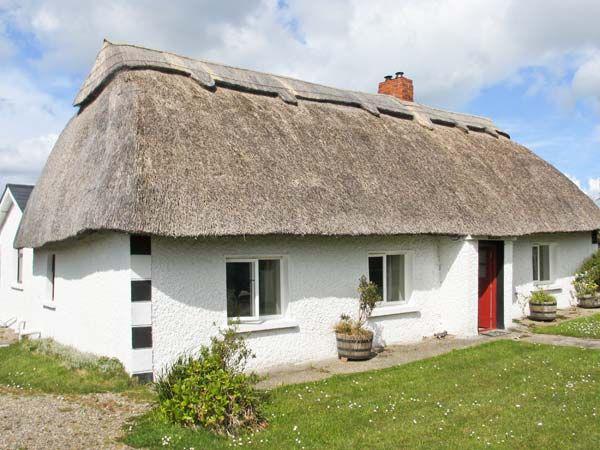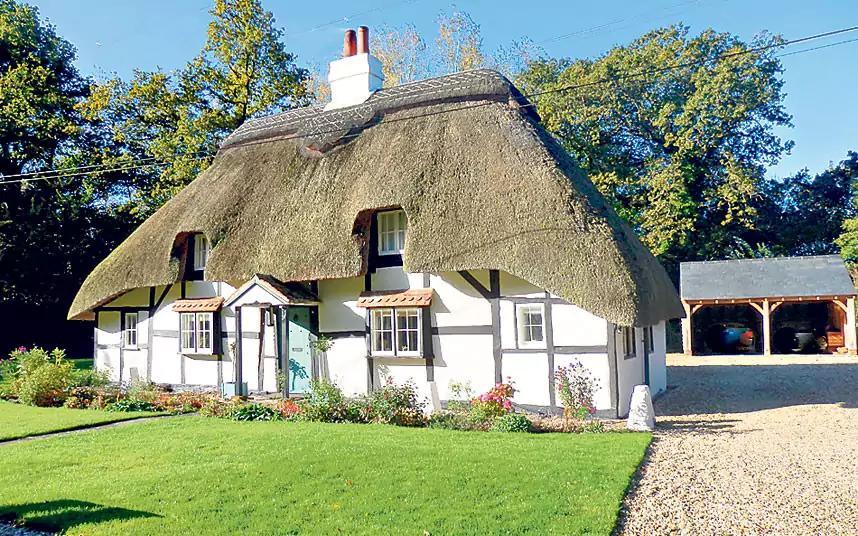The first image is the image on the left, the second image is the image on the right. Analyze the images presented: Is the assertion "The house in the left image has one chimney." valid? Answer yes or no. Yes. The first image is the image on the left, the second image is the image on the right. Evaluate the accuracy of this statement regarding the images: "There are no fewer than 2 chimneys in the image on the left.". Is it true? Answer yes or no. No. 